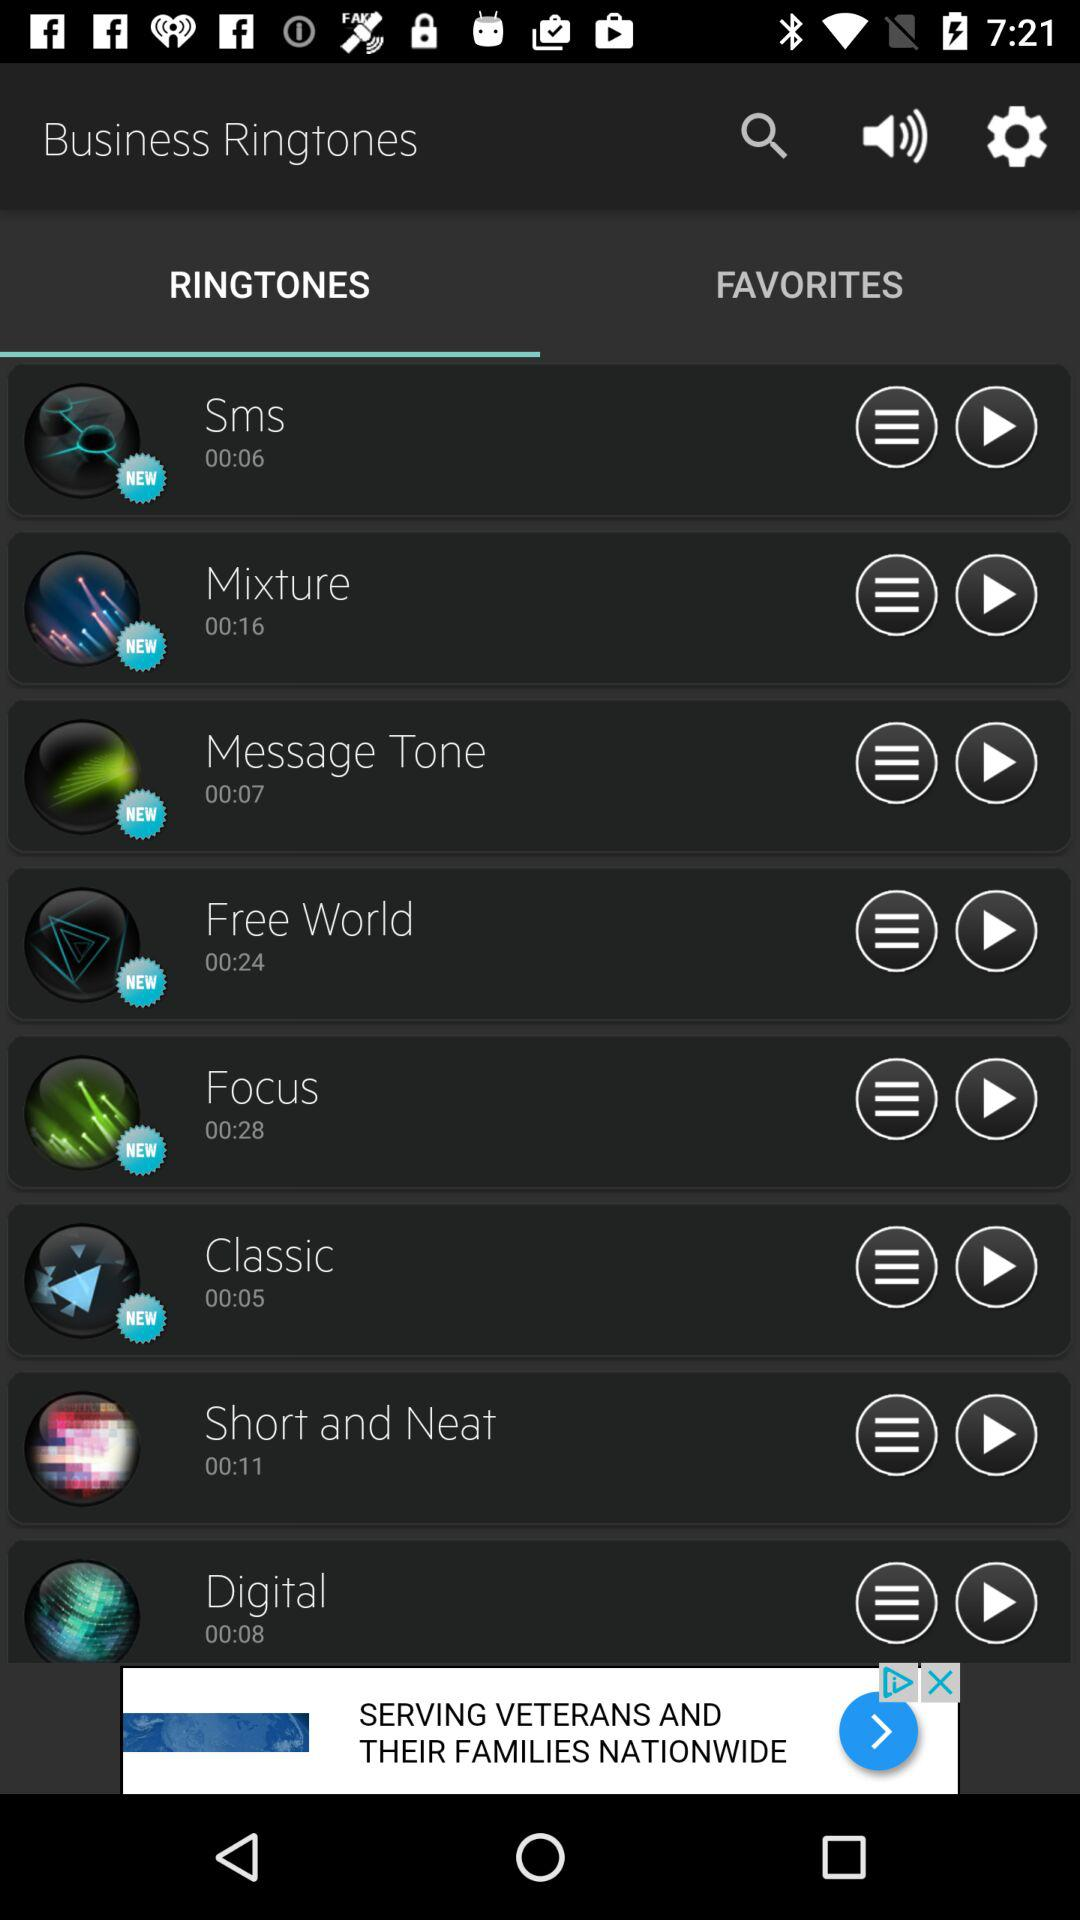Which tab is selected? The selected tab is "RINGTONES". 